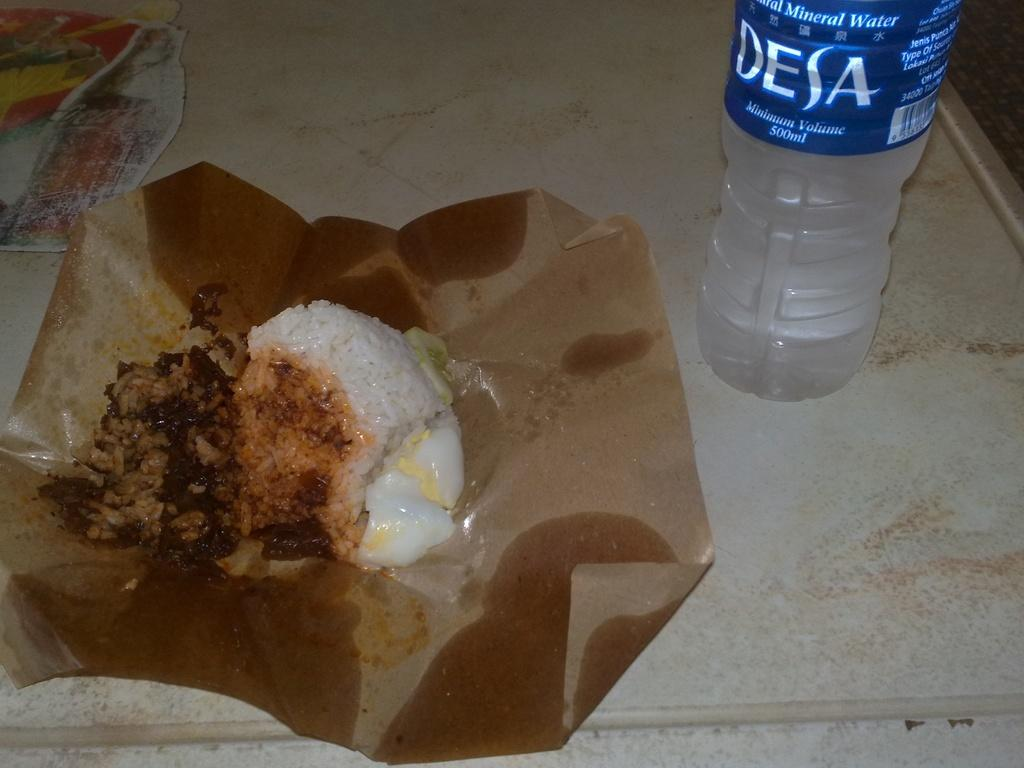What type of food is visible in the image? The food in the image is in a paper container. Can you describe the container holding the food? The food is in a paper container. What other item is visible in the image? There is a water bottle in the image. What is the name of the person who dropped the dime in the image? There is no dime or person present in the image. What type of trip is being taken in the image? There is no trip or indication of travel in the image. 